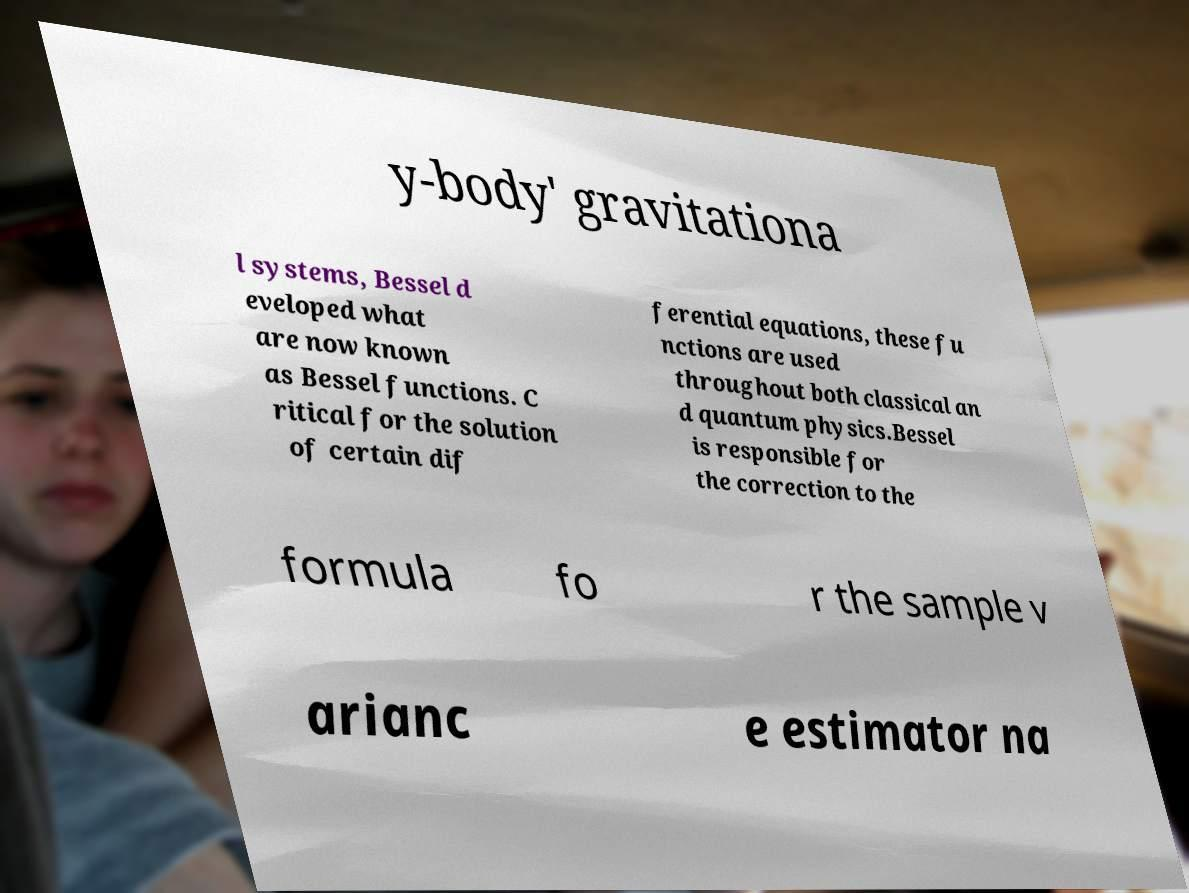Please read and relay the text visible in this image. What does it say? y-body' gravitationa l systems, Bessel d eveloped what are now known as Bessel functions. C ritical for the solution of certain dif ferential equations, these fu nctions are used throughout both classical an d quantum physics.Bessel is responsible for the correction to the formula fo r the sample v arianc e estimator na 